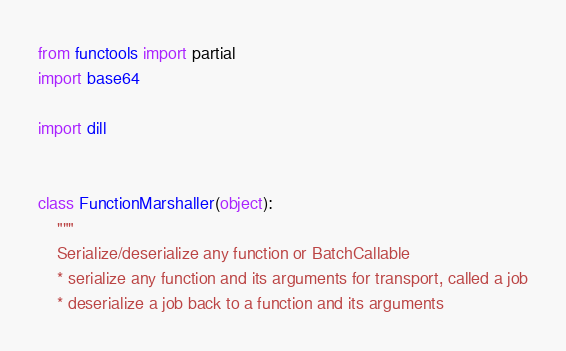<code> <loc_0><loc_0><loc_500><loc_500><_Python_>from functools import partial
import base64

import dill


class FunctionMarshaller(object):
    """
    Serialize/deserialize any function or BatchCallable
    * serialize any function and its arguments for transport, called a job
    * deserialize a job back to a function and its arguments</code> 